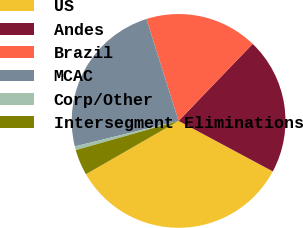Convert chart to OTSL. <chart><loc_0><loc_0><loc_500><loc_500><pie_chart><fcel>US<fcel>Andes<fcel>Brazil<fcel>MCAC<fcel>Corp/Other<fcel>Intersegment Eliminations<nl><fcel>33.86%<fcel>20.64%<fcel>17.05%<fcel>23.97%<fcel>0.57%<fcel>3.9%<nl></chart> 